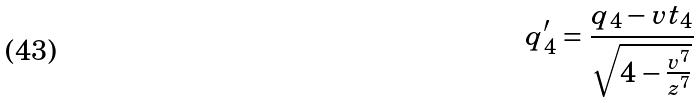<formula> <loc_0><loc_0><loc_500><loc_500>q _ { 4 } ^ { \prime } = \frac { q _ { 4 } - v t _ { 4 } } { \sqrt { 4 - \frac { v ^ { 7 } } { z ^ { 7 } } } }</formula> 